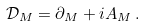Convert formula to latex. <formula><loc_0><loc_0><loc_500><loc_500>\mathcal { D } _ { M } = \partial _ { M } + i A _ { M } \, .</formula> 